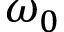<formula> <loc_0><loc_0><loc_500><loc_500>\omega _ { 0 }</formula> 